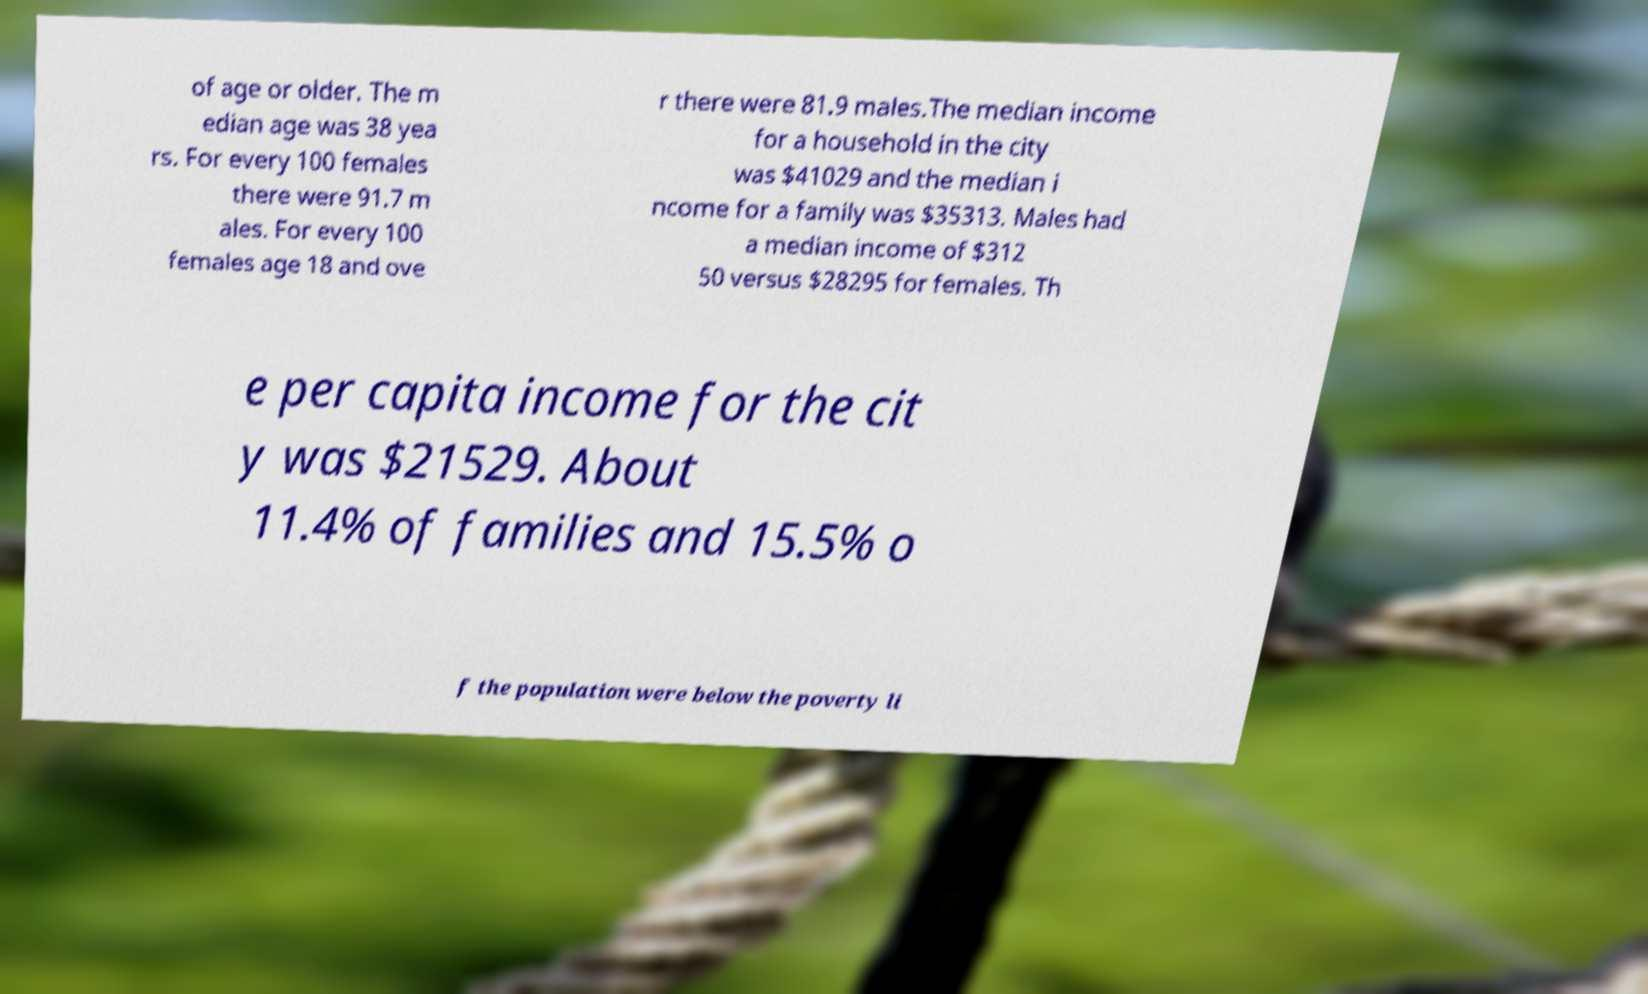For documentation purposes, I need the text within this image transcribed. Could you provide that? of age or older. The m edian age was 38 yea rs. For every 100 females there were 91.7 m ales. For every 100 females age 18 and ove r there were 81.9 males.The median income for a household in the city was $41029 and the median i ncome for a family was $35313. Males had a median income of $312 50 versus $28295 for females. Th e per capita income for the cit y was $21529. About 11.4% of families and 15.5% o f the population were below the poverty li 